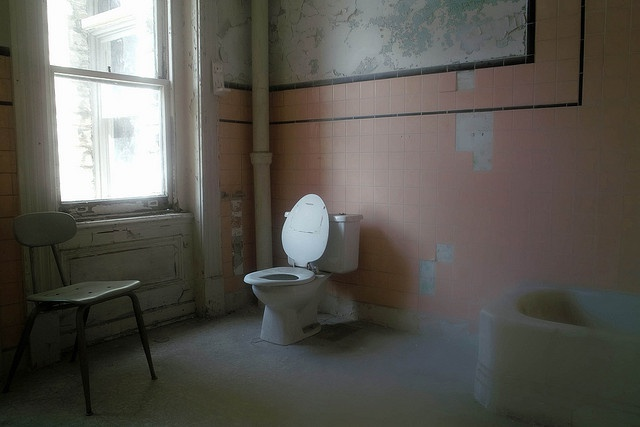Describe the objects in this image and their specific colors. I can see toilet in black, gray, and lightblue tones and chair in black and gray tones in this image. 